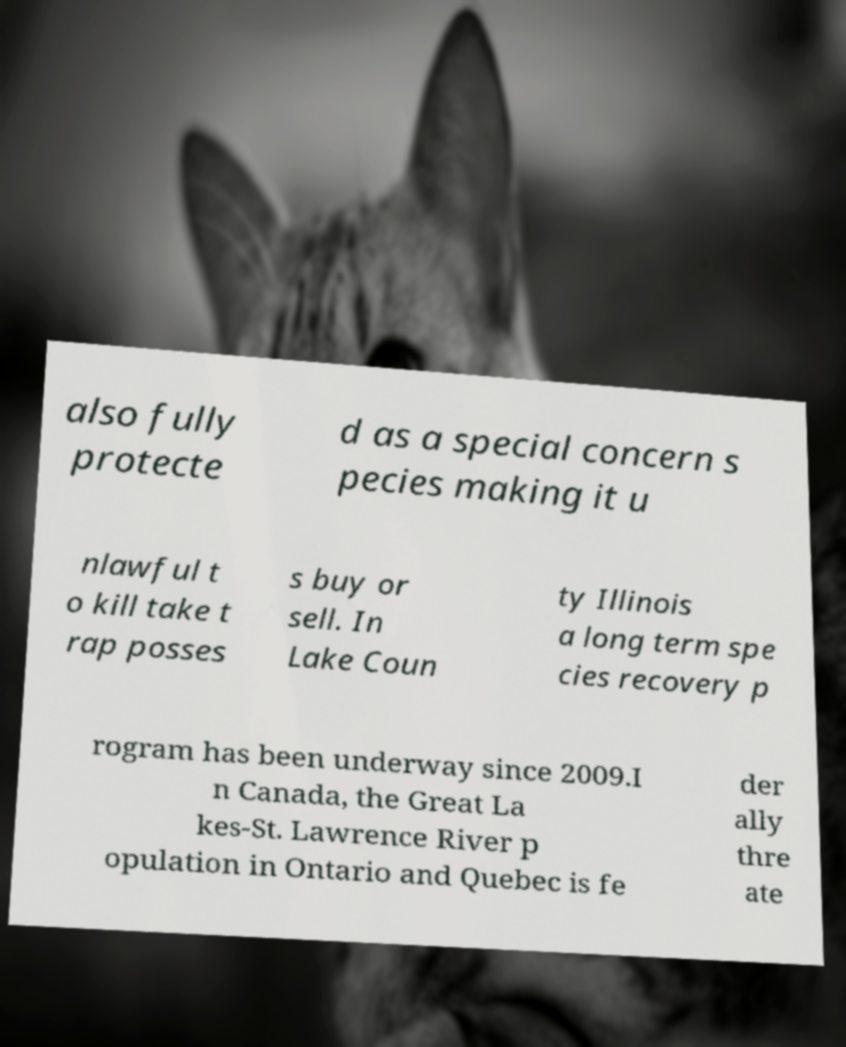Could you assist in decoding the text presented in this image and type it out clearly? also fully protecte d as a special concern s pecies making it u nlawful t o kill take t rap posses s buy or sell. In Lake Coun ty Illinois a long term spe cies recovery p rogram has been underway since 2009.I n Canada, the Great La kes-St. Lawrence River p opulation in Ontario and Quebec is fe der ally thre ate 